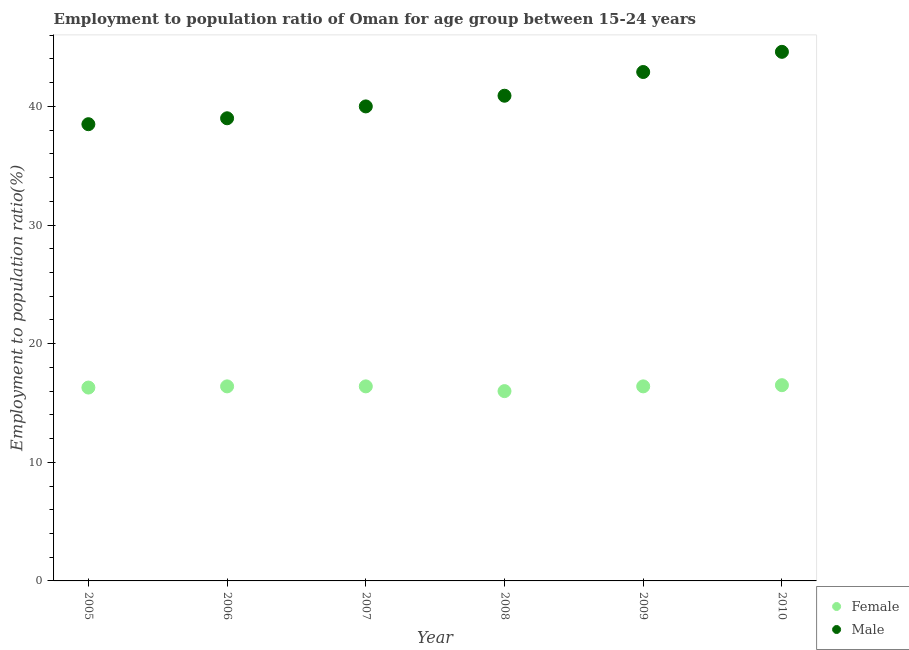How many different coloured dotlines are there?
Provide a succinct answer. 2. Is the number of dotlines equal to the number of legend labels?
Offer a terse response. Yes. What is the employment to population ratio(female) in 2007?
Ensure brevity in your answer.  16.4. Across all years, what is the maximum employment to population ratio(male)?
Provide a short and direct response. 44.6. What is the total employment to population ratio(female) in the graph?
Your answer should be compact. 98. What is the difference between the employment to population ratio(female) in 2007 and that in 2010?
Provide a short and direct response. -0.1. What is the difference between the employment to population ratio(female) in 2006 and the employment to population ratio(male) in 2009?
Offer a very short reply. -26.5. What is the average employment to population ratio(male) per year?
Give a very brief answer. 40.98. In the year 2007, what is the difference between the employment to population ratio(male) and employment to population ratio(female)?
Offer a very short reply. 23.6. What is the ratio of the employment to population ratio(female) in 2006 to that in 2010?
Provide a succinct answer. 0.99. What is the difference between the highest and the second highest employment to population ratio(female)?
Your response must be concise. 0.1. What is the difference between the highest and the lowest employment to population ratio(male)?
Your answer should be very brief. 6.1. Is the sum of the employment to population ratio(female) in 2007 and 2008 greater than the maximum employment to population ratio(male) across all years?
Provide a short and direct response. No. Does the employment to population ratio(male) monotonically increase over the years?
Offer a very short reply. Yes. Is the employment to population ratio(female) strictly greater than the employment to population ratio(male) over the years?
Offer a terse response. No. What is the difference between two consecutive major ticks on the Y-axis?
Offer a terse response. 10. Where does the legend appear in the graph?
Keep it short and to the point. Bottom right. What is the title of the graph?
Give a very brief answer. Employment to population ratio of Oman for age group between 15-24 years. Does "Sanitation services" appear as one of the legend labels in the graph?
Make the answer very short. No. What is the label or title of the X-axis?
Offer a terse response. Year. What is the label or title of the Y-axis?
Keep it short and to the point. Employment to population ratio(%). What is the Employment to population ratio(%) in Female in 2005?
Give a very brief answer. 16.3. What is the Employment to population ratio(%) of Male in 2005?
Your answer should be very brief. 38.5. What is the Employment to population ratio(%) of Female in 2006?
Offer a very short reply. 16.4. What is the Employment to population ratio(%) of Female in 2007?
Provide a succinct answer. 16.4. What is the Employment to population ratio(%) in Male in 2007?
Ensure brevity in your answer.  40. What is the Employment to population ratio(%) in Male in 2008?
Give a very brief answer. 40.9. What is the Employment to population ratio(%) of Female in 2009?
Make the answer very short. 16.4. What is the Employment to population ratio(%) in Male in 2009?
Provide a succinct answer. 42.9. What is the Employment to population ratio(%) of Male in 2010?
Your response must be concise. 44.6. Across all years, what is the maximum Employment to population ratio(%) of Female?
Your answer should be very brief. 16.5. Across all years, what is the maximum Employment to population ratio(%) of Male?
Keep it short and to the point. 44.6. Across all years, what is the minimum Employment to population ratio(%) of Male?
Provide a short and direct response. 38.5. What is the total Employment to population ratio(%) in Female in the graph?
Provide a short and direct response. 98. What is the total Employment to population ratio(%) in Male in the graph?
Offer a very short reply. 245.9. What is the difference between the Employment to population ratio(%) in Female in 2005 and that in 2006?
Your answer should be compact. -0.1. What is the difference between the Employment to population ratio(%) in Male in 2005 and that in 2006?
Give a very brief answer. -0.5. What is the difference between the Employment to population ratio(%) in Female in 2005 and that in 2007?
Provide a succinct answer. -0.1. What is the difference between the Employment to population ratio(%) in Male in 2005 and that in 2008?
Keep it short and to the point. -2.4. What is the difference between the Employment to population ratio(%) in Female in 2005 and that in 2010?
Your answer should be very brief. -0.2. What is the difference between the Employment to population ratio(%) of Male in 2005 and that in 2010?
Offer a very short reply. -6.1. What is the difference between the Employment to population ratio(%) of Male in 2006 and that in 2007?
Your answer should be very brief. -1. What is the difference between the Employment to population ratio(%) in Male in 2006 and that in 2008?
Keep it short and to the point. -1.9. What is the difference between the Employment to population ratio(%) in Female in 2006 and that in 2009?
Offer a very short reply. 0. What is the difference between the Employment to population ratio(%) of Male in 2006 and that in 2009?
Keep it short and to the point. -3.9. What is the difference between the Employment to population ratio(%) of Female in 2006 and that in 2010?
Provide a succinct answer. -0.1. What is the difference between the Employment to population ratio(%) of Female in 2007 and that in 2008?
Offer a terse response. 0.4. What is the difference between the Employment to population ratio(%) of Male in 2007 and that in 2008?
Provide a short and direct response. -0.9. What is the difference between the Employment to population ratio(%) in Female in 2007 and that in 2010?
Give a very brief answer. -0.1. What is the difference between the Employment to population ratio(%) of Male in 2007 and that in 2010?
Provide a short and direct response. -4.6. What is the difference between the Employment to population ratio(%) in Female in 2008 and that in 2009?
Give a very brief answer. -0.4. What is the difference between the Employment to population ratio(%) in Male in 2008 and that in 2009?
Ensure brevity in your answer.  -2. What is the difference between the Employment to population ratio(%) in Female in 2008 and that in 2010?
Your answer should be very brief. -0.5. What is the difference between the Employment to population ratio(%) of Female in 2009 and that in 2010?
Your answer should be very brief. -0.1. What is the difference between the Employment to population ratio(%) in Female in 2005 and the Employment to population ratio(%) in Male in 2006?
Provide a short and direct response. -22.7. What is the difference between the Employment to population ratio(%) in Female in 2005 and the Employment to population ratio(%) in Male in 2007?
Provide a short and direct response. -23.7. What is the difference between the Employment to population ratio(%) in Female in 2005 and the Employment to population ratio(%) in Male in 2008?
Offer a terse response. -24.6. What is the difference between the Employment to population ratio(%) of Female in 2005 and the Employment to population ratio(%) of Male in 2009?
Provide a succinct answer. -26.6. What is the difference between the Employment to population ratio(%) in Female in 2005 and the Employment to population ratio(%) in Male in 2010?
Keep it short and to the point. -28.3. What is the difference between the Employment to population ratio(%) of Female in 2006 and the Employment to population ratio(%) of Male in 2007?
Offer a very short reply. -23.6. What is the difference between the Employment to population ratio(%) of Female in 2006 and the Employment to population ratio(%) of Male in 2008?
Offer a terse response. -24.5. What is the difference between the Employment to population ratio(%) in Female in 2006 and the Employment to population ratio(%) in Male in 2009?
Your response must be concise. -26.5. What is the difference between the Employment to population ratio(%) in Female in 2006 and the Employment to population ratio(%) in Male in 2010?
Provide a short and direct response. -28.2. What is the difference between the Employment to population ratio(%) in Female in 2007 and the Employment to population ratio(%) in Male in 2008?
Provide a succinct answer. -24.5. What is the difference between the Employment to population ratio(%) in Female in 2007 and the Employment to population ratio(%) in Male in 2009?
Give a very brief answer. -26.5. What is the difference between the Employment to population ratio(%) in Female in 2007 and the Employment to population ratio(%) in Male in 2010?
Ensure brevity in your answer.  -28.2. What is the difference between the Employment to population ratio(%) of Female in 2008 and the Employment to population ratio(%) of Male in 2009?
Your answer should be very brief. -26.9. What is the difference between the Employment to population ratio(%) in Female in 2008 and the Employment to population ratio(%) in Male in 2010?
Offer a very short reply. -28.6. What is the difference between the Employment to population ratio(%) in Female in 2009 and the Employment to population ratio(%) in Male in 2010?
Your answer should be very brief. -28.2. What is the average Employment to population ratio(%) in Female per year?
Offer a very short reply. 16.33. What is the average Employment to population ratio(%) in Male per year?
Provide a short and direct response. 40.98. In the year 2005, what is the difference between the Employment to population ratio(%) of Female and Employment to population ratio(%) of Male?
Provide a succinct answer. -22.2. In the year 2006, what is the difference between the Employment to population ratio(%) in Female and Employment to population ratio(%) in Male?
Give a very brief answer. -22.6. In the year 2007, what is the difference between the Employment to population ratio(%) in Female and Employment to population ratio(%) in Male?
Offer a terse response. -23.6. In the year 2008, what is the difference between the Employment to population ratio(%) of Female and Employment to population ratio(%) of Male?
Give a very brief answer. -24.9. In the year 2009, what is the difference between the Employment to population ratio(%) in Female and Employment to population ratio(%) in Male?
Keep it short and to the point. -26.5. In the year 2010, what is the difference between the Employment to population ratio(%) in Female and Employment to population ratio(%) in Male?
Provide a succinct answer. -28.1. What is the ratio of the Employment to population ratio(%) of Male in 2005 to that in 2006?
Your answer should be very brief. 0.99. What is the ratio of the Employment to population ratio(%) in Male in 2005 to that in 2007?
Provide a succinct answer. 0.96. What is the ratio of the Employment to population ratio(%) in Female in 2005 to that in 2008?
Make the answer very short. 1.02. What is the ratio of the Employment to population ratio(%) of Male in 2005 to that in 2008?
Offer a terse response. 0.94. What is the ratio of the Employment to population ratio(%) in Female in 2005 to that in 2009?
Give a very brief answer. 0.99. What is the ratio of the Employment to population ratio(%) in Male in 2005 to that in 2009?
Make the answer very short. 0.9. What is the ratio of the Employment to population ratio(%) in Female in 2005 to that in 2010?
Keep it short and to the point. 0.99. What is the ratio of the Employment to population ratio(%) of Male in 2005 to that in 2010?
Offer a terse response. 0.86. What is the ratio of the Employment to population ratio(%) of Male in 2006 to that in 2008?
Provide a short and direct response. 0.95. What is the ratio of the Employment to population ratio(%) in Female in 2006 to that in 2009?
Your answer should be very brief. 1. What is the ratio of the Employment to population ratio(%) of Female in 2006 to that in 2010?
Make the answer very short. 0.99. What is the ratio of the Employment to population ratio(%) of Male in 2006 to that in 2010?
Provide a short and direct response. 0.87. What is the ratio of the Employment to population ratio(%) of Female in 2007 to that in 2008?
Provide a short and direct response. 1.02. What is the ratio of the Employment to population ratio(%) in Male in 2007 to that in 2009?
Keep it short and to the point. 0.93. What is the ratio of the Employment to population ratio(%) of Female in 2007 to that in 2010?
Offer a terse response. 0.99. What is the ratio of the Employment to population ratio(%) in Male in 2007 to that in 2010?
Keep it short and to the point. 0.9. What is the ratio of the Employment to population ratio(%) in Female in 2008 to that in 2009?
Your answer should be compact. 0.98. What is the ratio of the Employment to population ratio(%) of Male in 2008 to that in 2009?
Provide a succinct answer. 0.95. What is the ratio of the Employment to population ratio(%) of Female in 2008 to that in 2010?
Keep it short and to the point. 0.97. What is the ratio of the Employment to population ratio(%) in Male in 2008 to that in 2010?
Provide a succinct answer. 0.92. What is the ratio of the Employment to population ratio(%) of Female in 2009 to that in 2010?
Keep it short and to the point. 0.99. What is the ratio of the Employment to population ratio(%) in Male in 2009 to that in 2010?
Offer a terse response. 0.96. What is the difference between the highest and the second highest Employment to population ratio(%) of Female?
Keep it short and to the point. 0.1. What is the difference between the highest and the second highest Employment to population ratio(%) of Male?
Provide a succinct answer. 1.7. What is the difference between the highest and the lowest Employment to population ratio(%) of Male?
Give a very brief answer. 6.1. 